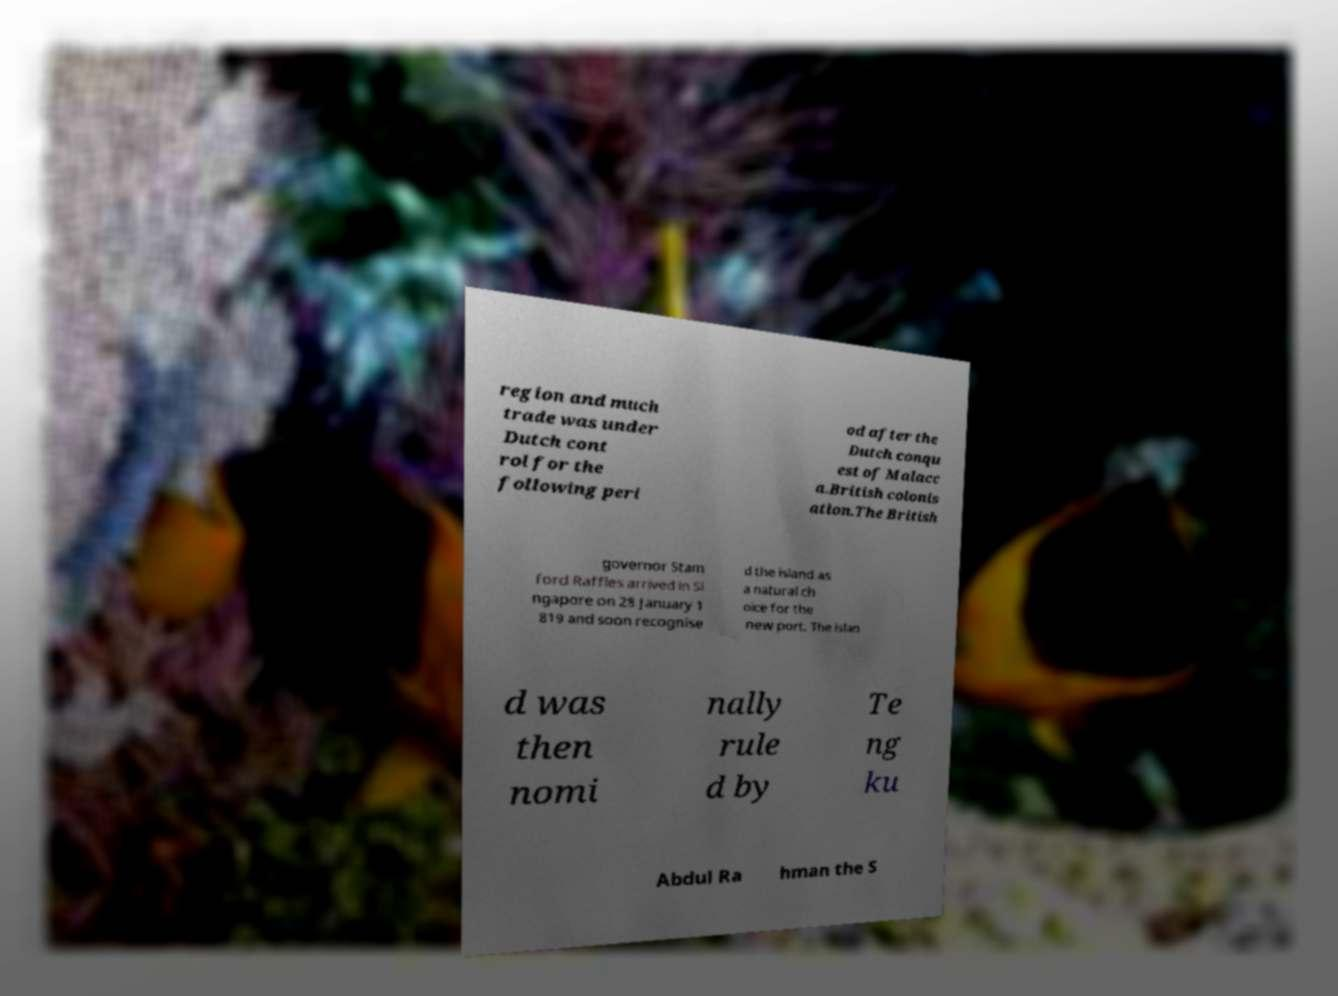Could you assist in decoding the text presented in this image and type it out clearly? region and much trade was under Dutch cont rol for the following peri od after the Dutch conqu est of Malacc a.British colonis ation.The British governor Stam ford Raffles arrived in Si ngapore on 28 January 1 819 and soon recognise d the island as a natural ch oice for the new port. The islan d was then nomi nally rule d by Te ng ku Abdul Ra hman the S 